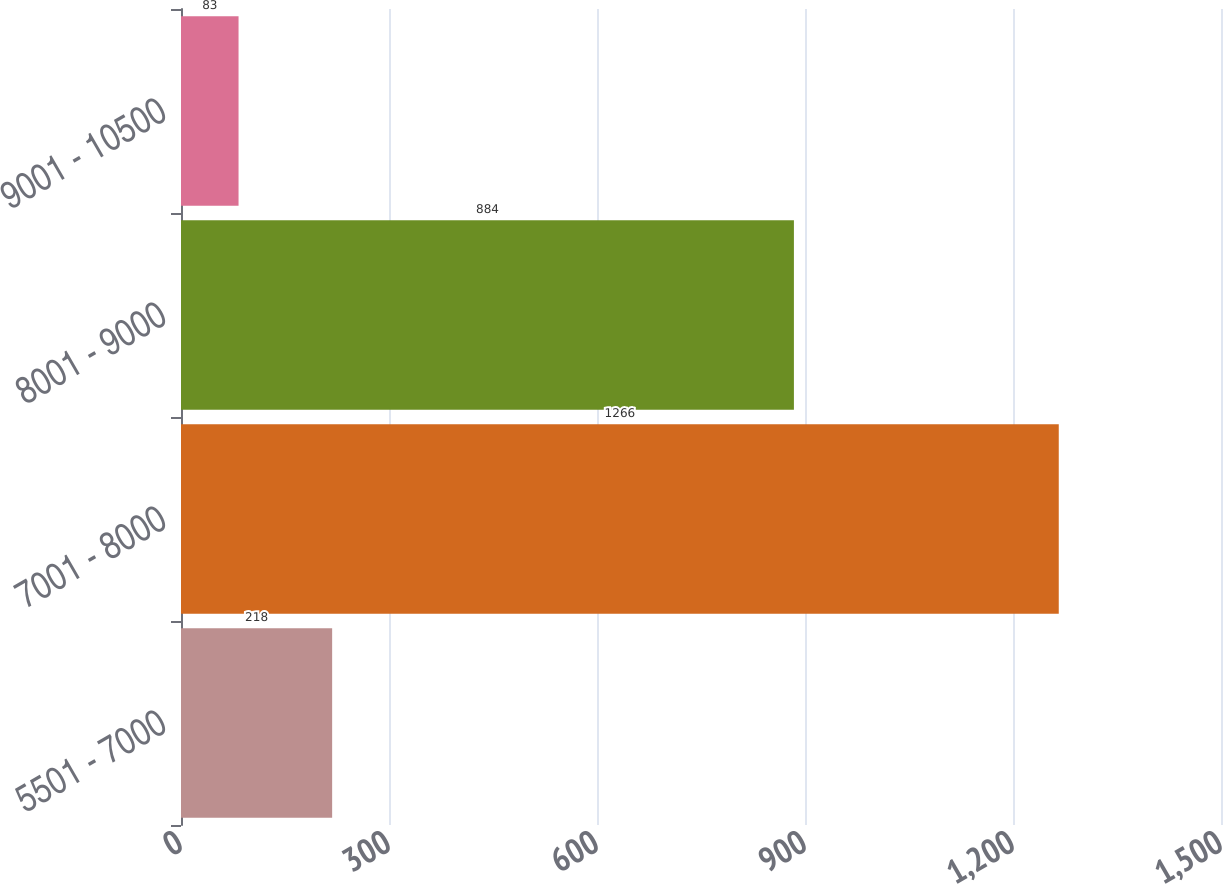Convert chart. <chart><loc_0><loc_0><loc_500><loc_500><bar_chart><fcel>5501 - 7000<fcel>7001 - 8000<fcel>8001 - 9000<fcel>9001 - 10500<nl><fcel>218<fcel>1266<fcel>884<fcel>83<nl></chart> 